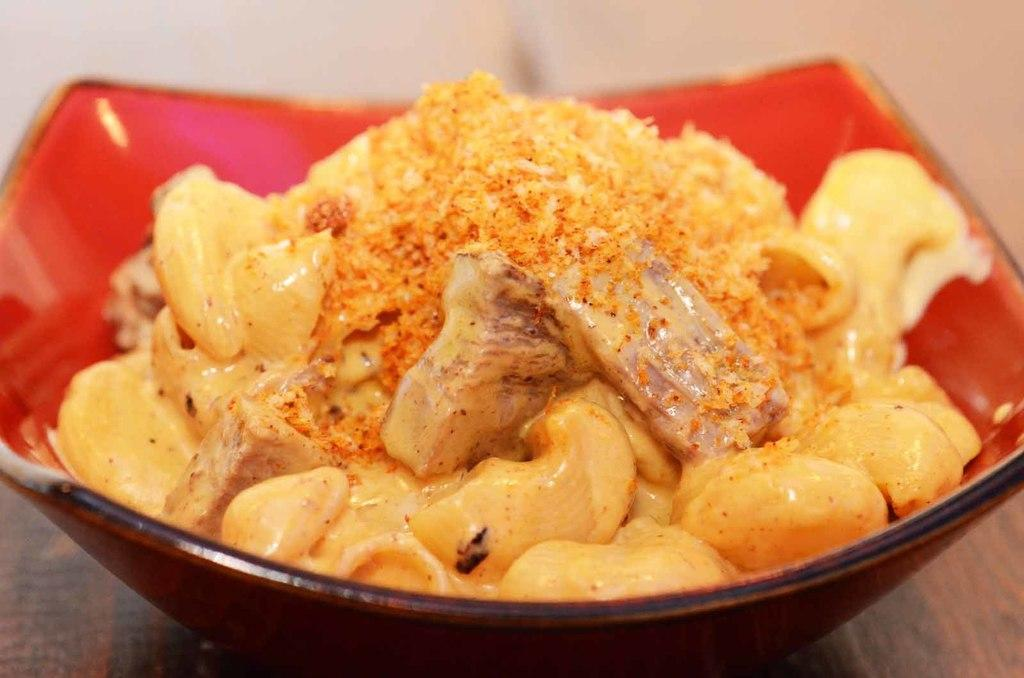What object is present on the table in the image? There is a bowl on the table in the image. What is the purpose of the bowl in the image? The bowl is serving food in the image. What type of worm can be seen crawling on the food in the image? There are no worms present in the image; it only shows a bowl of food on a table. 